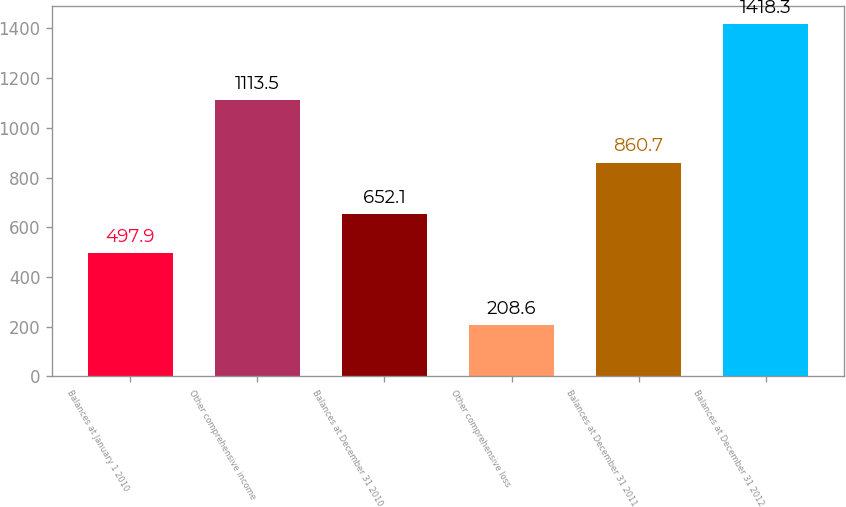<chart> <loc_0><loc_0><loc_500><loc_500><bar_chart><fcel>Balances at January 1 2010<fcel>Other comprehensive income<fcel>Balances at December 31 2010<fcel>Other comprehensive loss<fcel>Balances at December 31 2011<fcel>Balances at December 31 2012<nl><fcel>497.9<fcel>1113.5<fcel>652.1<fcel>208.6<fcel>860.7<fcel>1418.3<nl></chart> 